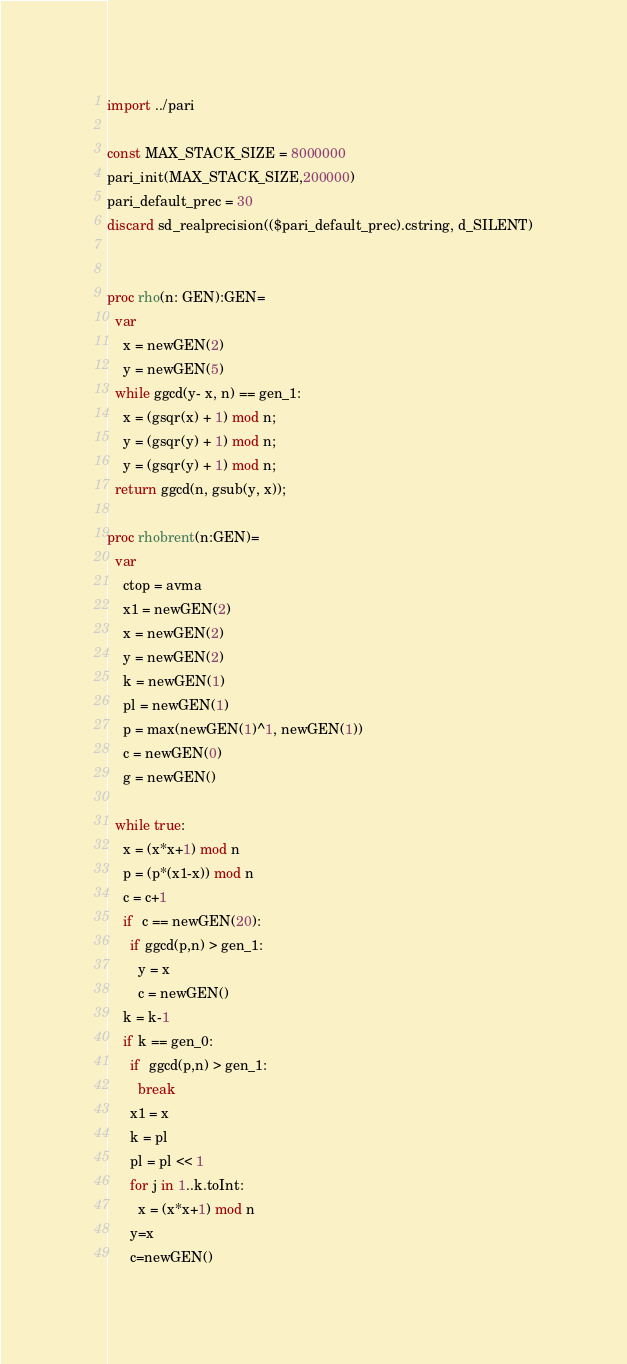Convert code to text. <code><loc_0><loc_0><loc_500><loc_500><_Nim_>import ../pari

const MAX_STACK_SIZE = 8000000
pari_init(MAX_STACK_SIZE,200000)
pari_default_prec = 30
discard sd_realprecision(($pari_default_prec).cstring, d_SILENT)


proc rho(n: GEN):GEN=
  var
    x = newGEN(2)
    y = newGEN(5)
  while ggcd(y- x, n) == gen_1:
    x = (gsqr(x) + 1) mod n;
    y = (gsqr(y) + 1) mod n;
    y = (gsqr(y) + 1) mod n;
  return ggcd(n, gsub(y, x));

proc rhobrent(n:GEN)=
  var
    ctop = avma
    x1 = newGEN(2)
    x = newGEN(2)
    y = newGEN(2)
    k = newGEN(1)
    pl = newGEN(1)
    p = max(newGEN(1)^1, newGEN(1))
    c = newGEN(0)
    g = newGEN()

  while true:
    x = (x*x+1) mod n
    p = (p*(x1-x)) mod n
    c = c+1
    if  c == newGEN(20):
      if ggcd(p,n) > gen_1:
        y = x
        c = newGEN()
    k = k-1
    if k == gen_0:
      if  ggcd(p,n) > gen_1:
        break
      x1 = x
      k = pl
      pl = pl << 1
      for j in 1..k.toInt:
        x = (x*x+1) mod n
      y=x
      c=newGEN()
</code> 